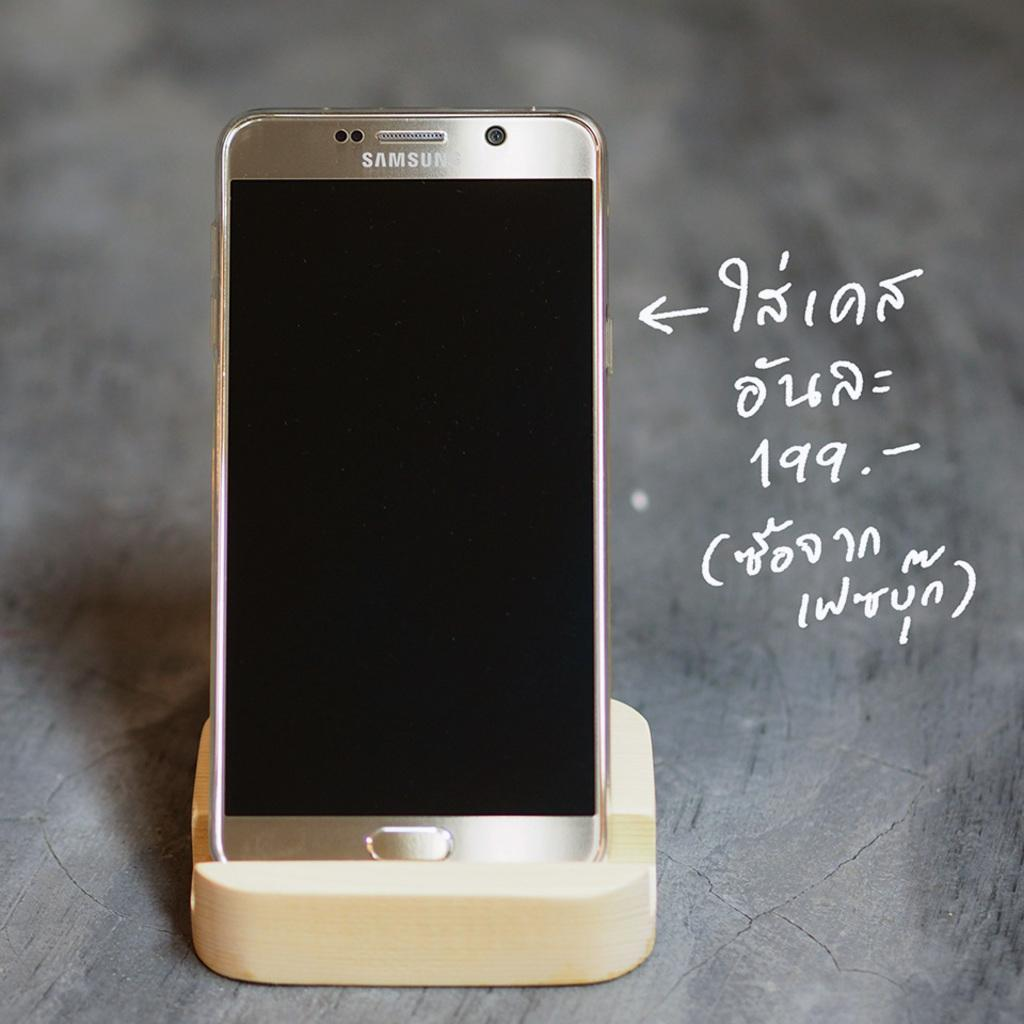<image>
Present a compact description of the photo's key features. a shiny Samsung phone on a wooden pedestal 